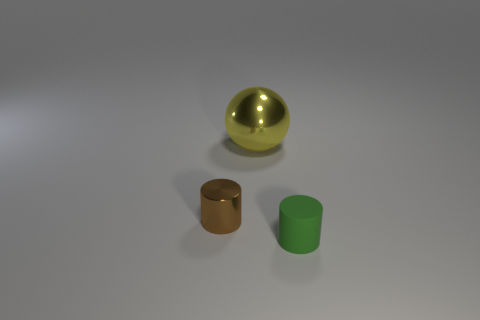Is there anything else that has the same material as the small green object?
Provide a succinct answer. No. What is the size of the metal thing that is right of the brown thing?
Offer a terse response. Large. How many things are big yellow balls or objects in front of the large sphere?
Your answer should be very brief. 3. What number of other objects are there of the same size as the green matte thing?
Ensure brevity in your answer.  1. There is another green object that is the same shape as the small metallic thing; what is it made of?
Ensure brevity in your answer.  Rubber. Is the number of brown cylinders that are on the left side of the sphere greater than the number of big yellow cylinders?
Ensure brevity in your answer.  Yes. Is there any other thing that has the same color as the big metal sphere?
Offer a very short reply. No. There is a tiny object that is the same material as the large yellow ball; what shape is it?
Offer a terse response. Cylinder. Do the tiny thing that is behind the green cylinder and the yellow thing have the same material?
Give a very brief answer. Yes. How many things are behind the brown metallic thing and on the right side of the big object?
Your answer should be very brief. 0. 